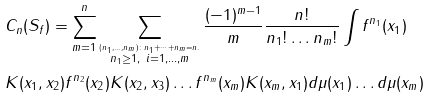Convert formula to latex. <formula><loc_0><loc_0><loc_500><loc_500>& C _ { n } ( S _ { f } ) = \sum ^ { n } _ { m = 1 } \sum _ { \overset { ( n _ { 1 } , \dots , n _ { m } ) \colon n _ { 1 } + \dots + n _ { m } = n . } { n _ { 1 } \geq 1 , \ i = 1 , \dots , m } } \frac { ( - 1 ) ^ { m - 1 } } { m } \frac { n ! } { n _ { 1 } ! \dots n _ { m } ! } \int f ^ { n _ { 1 } } ( x _ { 1 } ) \\ & K ( x _ { 1 } , x _ { 2 } ) f ^ { n _ { 2 } } ( x _ { 2 } ) K ( x _ { 2 } , x _ { 3 } ) \dots f ^ { n _ { m } } ( x _ { m } ) K ( x _ { m } , x _ { 1 } ) d \mu ( x _ { 1 } ) \dots d \mu ( x _ { m } )</formula> 